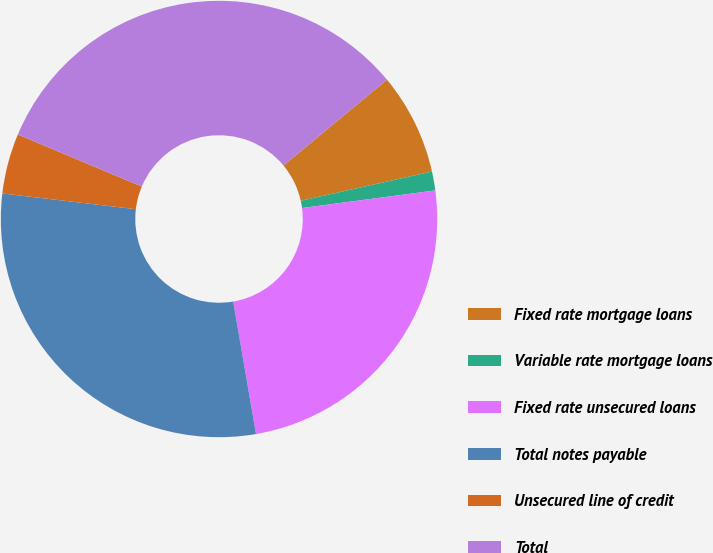<chart> <loc_0><loc_0><loc_500><loc_500><pie_chart><fcel>Fixed rate mortgage loans<fcel>Variable rate mortgage loans<fcel>Fixed rate unsecured loans<fcel>Total notes payable<fcel>Unsecured line of credit<fcel>Total<nl><fcel>7.53%<fcel>1.4%<fcel>24.38%<fcel>29.58%<fcel>4.46%<fcel>32.65%<nl></chart> 